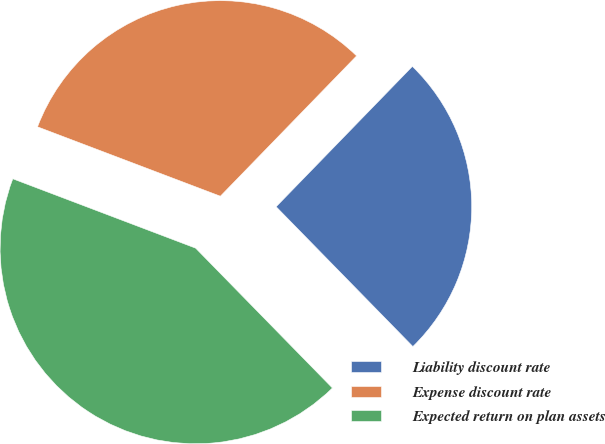<chart> <loc_0><loc_0><loc_500><loc_500><pie_chart><fcel>Liability discount rate<fcel>Expense discount rate<fcel>Expected return on plan assets<nl><fcel>25.41%<fcel>31.49%<fcel>43.09%<nl></chart> 